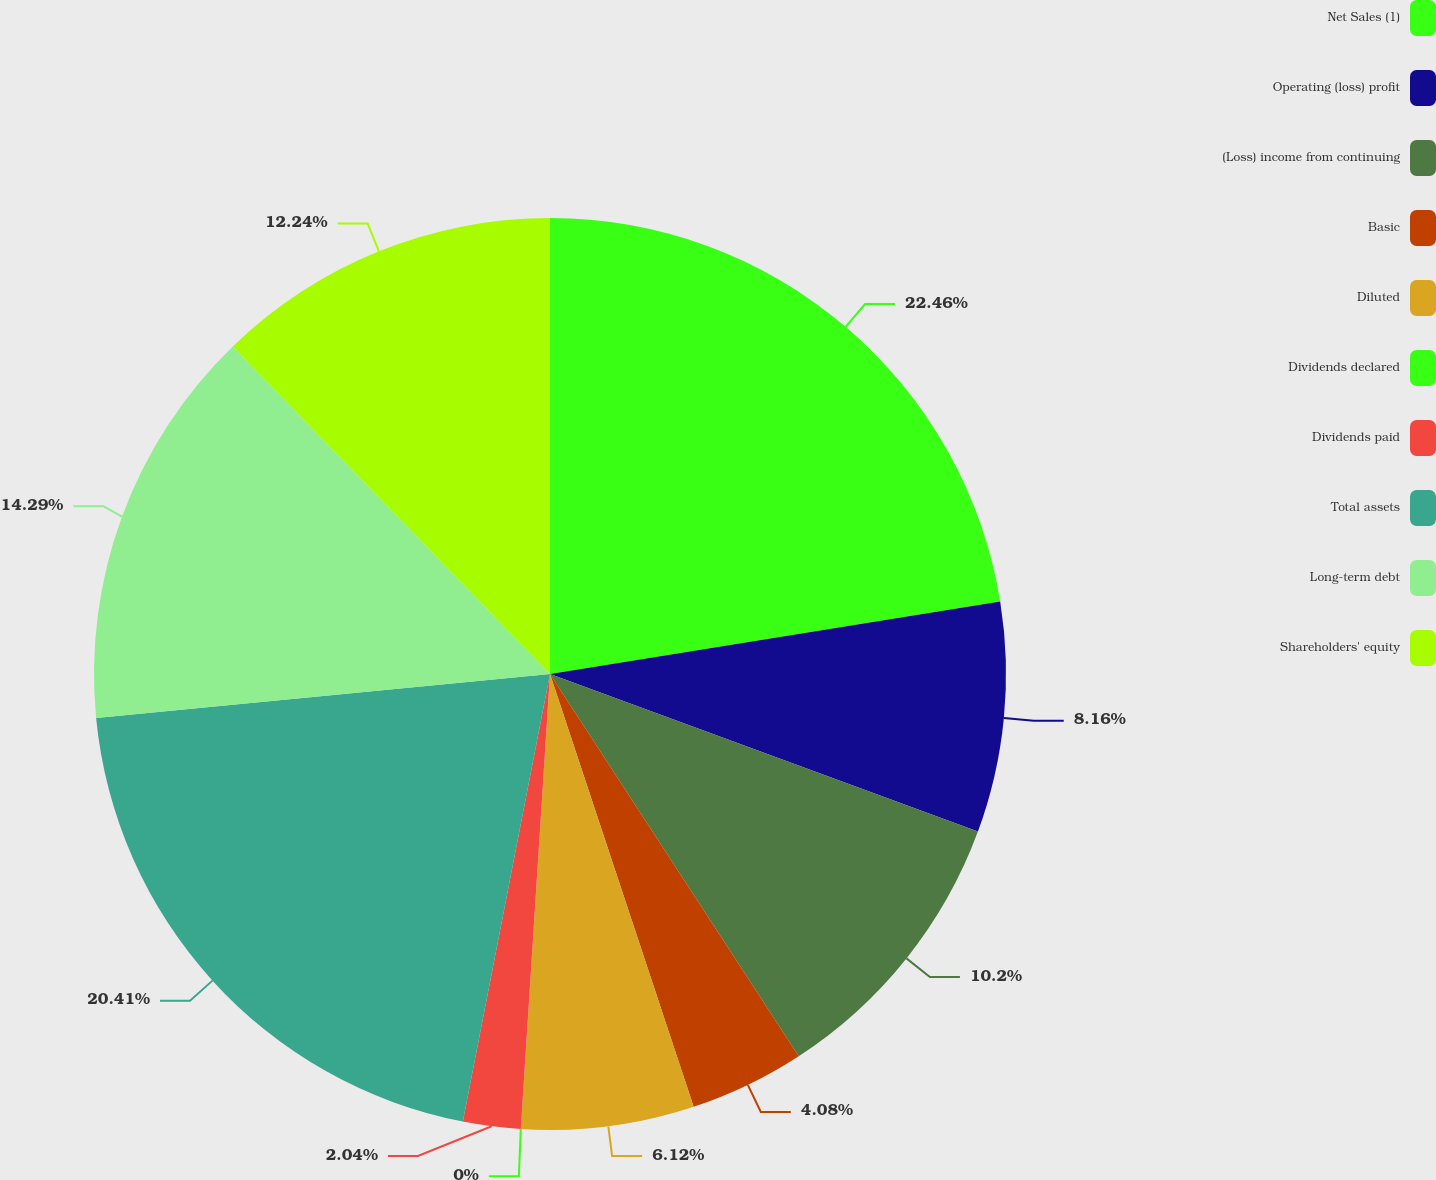Convert chart. <chart><loc_0><loc_0><loc_500><loc_500><pie_chart><fcel>Net Sales (1)<fcel>Operating (loss) profit<fcel>(Loss) income from continuing<fcel>Basic<fcel>Diluted<fcel>Dividends declared<fcel>Dividends paid<fcel>Total assets<fcel>Long-term debt<fcel>Shareholders' equity<nl><fcel>22.45%<fcel>8.16%<fcel>10.2%<fcel>4.08%<fcel>6.12%<fcel>0.0%<fcel>2.04%<fcel>20.4%<fcel>14.29%<fcel>12.24%<nl></chart> 